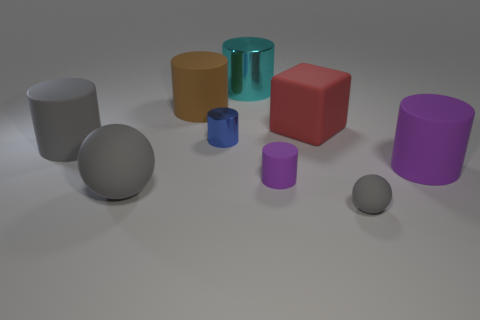What size is the red matte cube?
Offer a terse response. Large. Is there anything else that is made of the same material as the gray cylinder?
Provide a short and direct response. Yes. There is a sphere on the left side of the gray matte ball on the right side of the big matte ball; are there any tiny purple rubber things that are to the left of it?
Your response must be concise. No. What number of tiny objects are either purple things or brown cylinders?
Your response must be concise. 1. Is there anything else that has the same color as the block?
Provide a succinct answer. No. Does the metal thing that is in front of the brown object have the same size as the block?
Offer a terse response. No. What color is the sphere that is right of the ball to the left of the cyan cylinder to the left of the big purple object?
Make the answer very short. Gray. What color is the large block?
Provide a succinct answer. Red. Is the large sphere the same color as the small metallic thing?
Offer a very short reply. No. Do the ball left of the blue object and the gray object on the right side of the rubber block have the same material?
Offer a very short reply. Yes. 